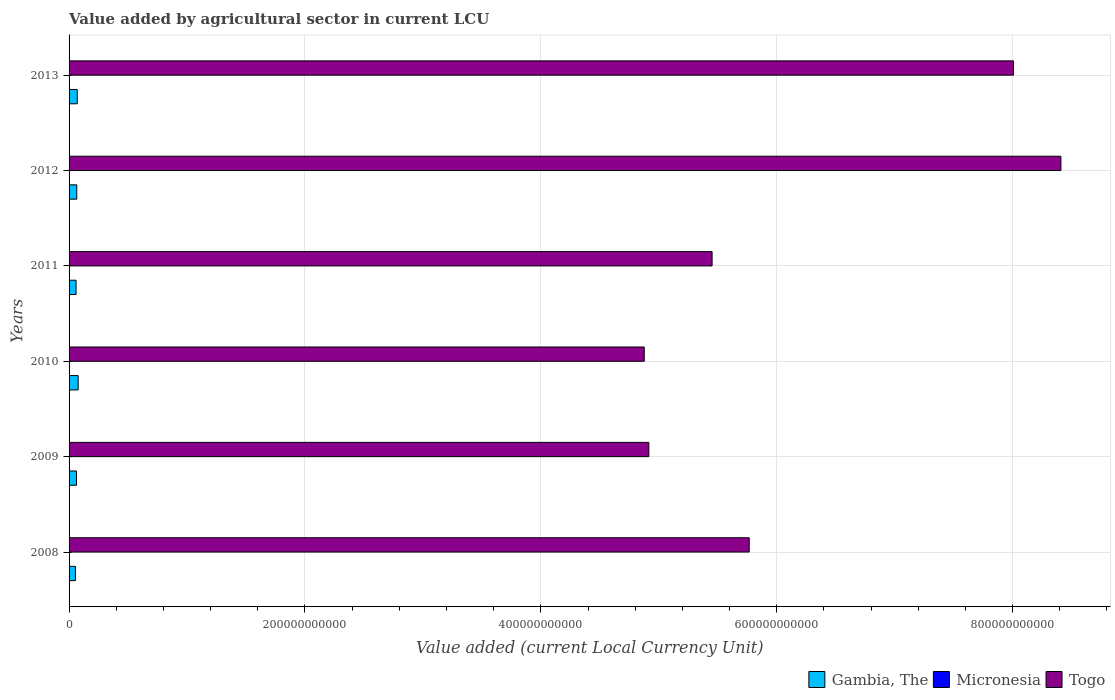Are the number of bars per tick equal to the number of legend labels?
Your response must be concise. Yes. Are the number of bars on each tick of the Y-axis equal?
Your answer should be compact. Yes. How many bars are there on the 3rd tick from the top?
Make the answer very short. 3. What is the label of the 6th group of bars from the top?
Offer a very short reply. 2008. In how many cases, is the number of bars for a given year not equal to the number of legend labels?
Offer a terse response. 0. What is the value added by agricultural sector in Togo in 2008?
Your answer should be very brief. 5.77e+11. Across all years, what is the maximum value added by agricultural sector in Micronesia?
Give a very brief answer. 9.16e+07. Across all years, what is the minimum value added by agricultural sector in Micronesia?
Your answer should be compact. 6.79e+07. In which year was the value added by agricultural sector in Micronesia maximum?
Give a very brief answer. 2012. What is the total value added by agricultural sector in Togo in the graph?
Give a very brief answer. 3.74e+12. What is the difference between the value added by agricultural sector in Togo in 2008 and that in 2012?
Give a very brief answer. -2.64e+11. What is the difference between the value added by agricultural sector in Micronesia in 2009 and the value added by agricultural sector in Gambia, The in 2012?
Make the answer very short. -6.46e+09. What is the average value added by agricultural sector in Micronesia per year?
Ensure brevity in your answer.  7.72e+07. In the year 2013, what is the difference between the value added by agricultural sector in Gambia, The and value added by agricultural sector in Micronesia?
Provide a short and direct response. 6.86e+09. What is the ratio of the value added by agricultural sector in Gambia, The in 2009 to that in 2010?
Offer a terse response. 0.82. What is the difference between the highest and the second highest value added by agricultural sector in Togo?
Your answer should be compact. 4.03e+1. What is the difference between the highest and the lowest value added by agricultural sector in Gambia, The?
Provide a succinct answer. 2.32e+09. What does the 3rd bar from the top in 2013 represents?
Your answer should be very brief. Gambia, The. What does the 3rd bar from the bottom in 2008 represents?
Offer a very short reply. Togo. Is it the case that in every year, the sum of the value added by agricultural sector in Togo and value added by agricultural sector in Micronesia is greater than the value added by agricultural sector in Gambia, The?
Your response must be concise. Yes. What is the difference between two consecutive major ticks on the X-axis?
Provide a succinct answer. 2.00e+11. Are the values on the major ticks of X-axis written in scientific E-notation?
Your response must be concise. No. Does the graph contain grids?
Your answer should be compact. Yes. Where does the legend appear in the graph?
Make the answer very short. Bottom right. How are the legend labels stacked?
Keep it short and to the point. Horizontal. What is the title of the graph?
Provide a succinct answer. Value added by agricultural sector in current LCU. What is the label or title of the X-axis?
Offer a very short reply. Value added (current Local Currency Unit). What is the label or title of the Y-axis?
Ensure brevity in your answer.  Years. What is the Value added (current Local Currency Unit) in Gambia, The in 2008?
Your answer should be very brief. 5.40e+09. What is the Value added (current Local Currency Unit) of Micronesia in 2008?
Make the answer very short. 6.79e+07. What is the Value added (current Local Currency Unit) in Togo in 2008?
Your answer should be compact. 5.77e+11. What is the Value added (current Local Currency Unit) in Gambia, The in 2009?
Ensure brevity in your answer.  6.29e+09. What is the Value added (current Local Currency Unit) in Micronesia in 2009?
Your answer should be compact. 6.84e+07. What is the Value added (current Local Currency Unit) of Togo in 2009?
Offer a very short reply. 4.92e+11. What is the Value added (current Local Currency Unit) of Gambia, The in 2010?
Give a very brief answer. 7.72e+09. What is the Value added (current Local Currency Unit) of Micronesia in 2010?
Provide a short and direct response. 7.13e+07. What is the Value added (current Local Currency Unit) of Togo in 2010?
Your answer should be very brief. 4.88e+11. What is the Value added (current Local Currency Unit) of Gambia, The in 2011?
Provide a short and direct response. 5.94e+09. What is the Value added (current Local Currency Unit) in Micronesia in 2011?
Offer a terse response. 8.02e+07. What is the Value added (current Local Currency Unit) in Togo in 2011?
Give a very brief answer. 5.45e+11. What is the Value added (current Local Currency Unit) of Gambia, The in 2012?
Your answer should be compact. 6.53e+09. What is the Value added (current Local Currency Unit) of Micronesia in 2012?
Your answer should be compact. 9.16e+07. What is the Value added (current Local Currency Unit) in Togo in 2012?
Offer a very short reply. 8.41e+11. What is the Value added (current Local Currency Unit) of Gambia, The in 2013?
Keep it short and to the point. 6.94e+09. What is the Value added (current Local Currency Unit) in Micronesia in 2013?
Keep it short and to the point. 8.35e+07. What is the Value added (current Local Currency Unit) in Togo in 2013?
Your response must be concise. 8.01e+11. Across all years, what is the maximum Value added (current Local Currency Unit) of Gambia, The?
Keep it short and to the point. 7.72e+09. Across all years, what is the maximum Value added (current Local Currency Unit) of Micronesia?
Your response must be concise. 9.16e+07. Across all years, what is the maximum Value added (current Local Currency Unit) of Togo?
Your response must be concise. 8.41e+11. Across all years, what is the minimum Value added (current Local Currency Unit) in Gambia, The?
Provide a succinct answer. 5.40e+09. Across all years, what is the minimum Value added (current Local Currency Unit) in Micronesia?
Your response must be concise. 6.79e+07. Across all years, what is the minimum Value added (current Local Currency Unit) of Togo?
Your answer should be very brief. 4.88e+11. What is the total Value added (current Local Currency Unit) in Gambia, The in the graph?
Offer a very short reply. 3.88e+1. What is the total Value added (current Local Currency Unit) in Micronesia in the graph?
Make the answer very short. 4.63e+08. What is the total Value added (current Local Currency Unit) in Togo in the graph?
Offer a terse response. 3.74e+12. What is the difference between the Value added (current Local Currency Unit) of Gambia, The in 2008 and that in 2009?
Your response must be concise. -8.91e+08. What is the difference between the Value added (current Local Currency Unit) of Micronesia in 2008 and that in 2009?
Your response must be concise. -5.00e+05. What is the difference between the Value added (current Local Currency Unit) in Togo in 2008 and that in 2009?
Keep it short and to the point. 8.51e+1. What is the difference between the Value added (current Local Currency Unit) in Gambia, The in 2008 and that in 2010?
Ensure brevity in your answer.  -2.32e+09. What is the difference between the Value added (current Local Currency Unit) of Micronesia in 2008 and that in 2010?
Offer a very short reply. -3.40e+06. What is the difference between the Value added (current Local Currency Unit) of Togo in 2008 and that in 2010?
Provide a succinct answer. 8.90e+1. What is the difference between the Value added (current Local Currency Unit) in Gambia, The in 2008 and that in 2011?
Your response must be concise. -5.41e+08. What is the difference between the Value added (current Local Currency Unit) in Micronesia in 2008 and that in 2011?
Your response must be concise. -1.23e+07. What is the difference between the Value added (current Local Currency Unit) of Togo in 2008 and that in 2011?
Offer a terse response. 3.15e+1. What is the difference between the Value added (current Local Currency Unit) of Gambia, The in 2008 and that in 2012?
Provide a short and direct response. -1.13e+09. What is the difference between the Value added (current Local Currency Unit) of Micronesia in 2008 and that in 2012?
Provide a short and direct response. -2.37e+07. What is the difference between the Value added (current Local Currency Unit) in Togo in 2008 and that in 2012?
Your answer should be compact. -2.64e+11. What is the difference between the Value added (current Local Currency Unit) in Gambia, The in 2008 and that in 2013?
Offer a terse response. -1.54e+09. What is the difference between the Value added (current Local Currency Unit) in Micronesia in 2008 and that in 2013?
Make the answer very short. -1.56e+07. What is the difference between the Value added (current Local Currency Unit) of Togo in 2008 and that in 2013?
Provide a succinct answer. -2.24e+11. What is the difference between the Value added (current Local Currency Unit) of Gambia, The in 2009 and that in 2010?
Your answer should be compact. -1.43e+09. What is the difference between the Value added (current Local Currency Unit) in Micronesia in 2009 and that in 2010?
Provide a succinct answer. -2.90e+06. What is the difference between the Value added (current Local Currency Unit) in Togo in 2009 and that in 2010?
Offer a terse response. 3.88e+09. What is the difference between the Value added (current Local Currency Unit) in Gambia, The in 2009 and that in 2011?
Offer a terse response. 3.50e+08. What is the difference between the Value added (current Local Currency Unit) of Micronesia in 2009 and that in 2011?
Provide a succinct answer. -1.18e+07. What is the difference between the Value added (current Local Currency Unit) of Togo in 2009 and that in 2011?
Offer a very short reply. -5.36e+1. What is the difference between the Value added (current Local Currency Unit) of Gambia, The in 2009 and that in 2012?
Keep it short and to the point. -2.41e+08. What is the difference between the Value added (current Local Currency Unit) of Micronesia in 2009 and that in 2012?
Offer a terse response. -2.32e+07. What is the difference between the Value added (current Local Currency Unit) of Togo in 2009 and that in 2012?
Provide a succinct answer. -3.49e+11. What is the difference between the Value added (current Local Currency Unit) of Gambia, The in 2009 and that in 2013?
Your response must be concise. -6.47e+08. What is the difference between the Value added (current Local Currency Unit) in Micronesia in 2009 and that in 2013?
Offer a very short reply. -1.51e+07. What is the difference between the Value added (current Local Currency Unit) in Togo in 2009 and that in 2013?
Your answer should be very brief. -3.09e+11. What is the difference between the Value added (current Local Currency Unit) of Gambia, The in 2010 and that in 2011?
Your answer should be compact. 1.78e+09. What is the difference between the Value added (current Local Currency Unit) of Micronesia in 2010 and that in 2011?
Your response must be concise. -8.90e+06. What is the difference between the Value added (current Local Currency Unit) in Togo in 2010 and that in 2011?
Offer a terse response. -5.75e+1. What is the difference between the Value added (current Local Currency Unit) of Gambia, The in 2010 and that in 2012?
Provide a short and direct response. 1.19e+09. What is the difference between the Value added (current Local Currency Unit) in Micronesia in 2010 and that in 2012?
Provide a short and direct response. -2.03e+07. What is the difference between the Value added (current Local Currency Unit) of Togo in 2010 and that in 2012?
Ensure brevity in your answer.  -3.53e+11. What is the difference between the Value added (current Local Currency Unit) in Gambia, The in 2010 and that in 2013?
Your answer should be very brief. 7.81e+08. What is the difference between the Value added (current Local Currency Unit) in Micronesia in 2010 and that in 2013?
Your response must be concise. -1.22e+07. What is the difference between the Value added (current Local Currency Unit) in Togo in 2010 and that in 2013?
Your answer should be compact. -3.13e+11. What is the difference between the Value added (current Local Currency Unit) of Gambia, The in 2011 and that in 2012?
Keep it short and to the point. -5.92e+08. What is the difference between the Value added (current Local Currency Unit) of Micronesia in 2011 and that in 2012?
Provide a short and direct response. -1.14e+07. What is the difference between the Value added (current Local Currency Unit) of Togo in 2011 and that in 2012?
Offer a very short reply. -2.96e+11. What is the difference between the Value added (current Local Currency Unit) in Gambia, The in 2011 and that in 2013?
Your answer should be very brief. -9.97e+08. What is the difference between the Value added (current Local Currency Unit) of Micronesia in 2011 and that in 2013?
Give a very brief answer. -3.30e+06. What is the difference between the Value added (current Local Currency Unit) of Togo in 2011 and that in 2013?
Keep it short and to the point. -2.55e+11. What is the difference between the Value added (current Local Currency Unit) in Gambia, The in 2012 and that in 2013?
Your response must be concise. -4.06e+08. What is the difference between the Value added (current Local Currency Unit) of Micronesia in 2012 and that in 2013?
Provide a short and direct response. 8.10e+06. What is the difference between the Value added (current Local Currency Unit) in Togo in 2012 and that in 2013?
Your answer should be very brief. 4.03e+1. What is the difference between the Value added (current Local Currency Unit) in Gambia, The in 2008 and the Value added (current Local Currency Unit) in Micronesia in 2009?
Your answer should be compact. 5.33e+09. What is the difference between the Value added (current Local Currency Unit) in Gambia, The in 2008 and the Value added (current Local Currency Unit) in Togo in 2009?
Your answer should be compact. -4.86e+11. What is the difference between the Value added (current Local Currency Unit) of Micronesia in 2008 and the Value added (current Local Currency Unit) of Togo in 2009?
Offer a very short reply. -4.91e+11. What is the difference between the Value added (current Local Currency Unit) in Gambia, The in 2008 and the Value added (current Local Currency Unit) in Micronesia in 2010?
Your response must be concise. 5.33e+09. What is the difference between the Value added (current Local Currency Unit) in Gambia, The in 2008 and the Value added (current Local Currency Unit) in Togo in 2010?
Provide a short and direct response. -4.82e+11. What is the difference between the Value added (current Local Currency Unit) of Micronesia in 2008 and the Value added (current Local Currency Unit) of Togo in 2010?
Give a very brief answer. -4.88e+11. What is the difference between the Value added (current Local Currency Unit) of Gambia, The in 2008 and the Value added (current Local Currency Unit) of Micronesia in 2011?
Provide a succinct answer. 5.32e+09. What is the difference between the Value added (current Local Currency Unit) of Gambia, The in 2008 and the Value added (current Local Currency Unit) of Togo in 2011?
Give a very brief answer. -5.40e+11. What is the difference between the Value added (current Local Currency Unit) in Micronesia in 2008 and the Value added (current Local Currency Unit) in Togo in 2011?
Offer a terse response. -5.45e+11. What is the difference between the Value added (current Local Currency Unit) in Gambia, The in 2008 and the Value added (current Local Currency Unit) in Micronesia in 2012?
Provide a succinct answer. 5.31e+09. What is the difference between the Value added (current Local Currency Unit) of Gambia, The in 2008 and the Value added (current Local Currency Unit) of Togo in 2012?
Your answer should be compact. -8.36e+11. What is the difference between the Value added (current Local Currency Unit) of Micronesia in 2008 and the Value added (current Local Currency Unit) of Togo in 2012?
Your answer should be compact. -8.41e+11. What is the difference between the Value added (current Local Currency Unit) in Gambia, The in 2008 and the Value added (current Local Currency Unit) in Micronesia in 2013?
Your answer should be very brief. 5.32e+09. What is the difference between the Value added (current Local Currency Unit) in Gambia, The in 2008 and the Value added (current Local Currency Unit) in Togo in 2013?
Keep it short and to the point. -7.95e+11. What is the difference between the Value added (current Local Currency Unit) of Micronesia in 2008 and the Value added (current Local Currency Unit) of Togo in 2013?
Your response must be concise. -8.01e+11. What is the difference between the Value added (current Local Currency Unit) of Gambia, The in 2009 and the Value added (current Local Currency Unit) of Micronesia in 2010?
Provide a short and direct response. 6.22e+09. What is the difference between the Value added (current Local Currency Unit) of Gambia, The in 2009 and the Value added (current Local Currency Unit) of Togo in 2010?
Provide a succinct answer. -4.81e+11. What is the difference between the Value added (current Local Currency Unit) of Micronesia in 2009 and the Value added (current Local Currency Unit) of Togo in 2010?
Keep it short and to the point. -4.88e+11. What is the difference between the Value added (current Local Currency Unit) in Gambia, The in 2009 and the Value added (current Local Currency Unit) in Micronesia in 2011?
Your answer should be very brief. 6.21e+09. What is the difference between the Value added (current Local Currency Unit) of Gambia, The in 2009 and the Value added (current Local Currency Unit) of Togo in 2011?
Ensure brevity in your answer.  -5.39e+11. What is the difference between the Value added (current Local Currency Unit) of Micronesia in 2009 and the Value added (current Local Currency Unit) of Togo in 2011?
Offer a very short reply. -5.45e+11. What is the difference between the Value added (current Local Currency Unit) of Gambia, The in 2009 and the Value added (current Local Currency Unit) of Micronesia in 2012?
Offer a very short reply. 6.20e+09. What is the difference between the Value added (current Local Currency Unit) in Gambia, The in 2009 and the Value added (current Local Currency Unit) in Togo in 2012?
Make the answer very short. -8.35e+11. What is the difference between the Value added (current Local Currency Unit) in Micronesia in 2009 and the Value added (current Local Currency Unit) in Togo in 2012?
Ensure brevity in your answer.  -8.41e+11. What is the difference between the Value added (current Local Currency Unit) of Gambia, The in 2009 and the Value added (current Local Currency Unit) of Micronesia in 2013?
Give a very brief answer. 6.21e+09. What is the difference between the Value added (current Local Currency Unit) in Gambia, The in 2009 and the Value added (current Local Currency Unit) in Togo in 2013?
Your answer should be very brief. -7.94e+11. What is the difference between the Value added (current Local Currency Unit) in Micronesia in 2009 and the Value added (current Local Currency Unit) in Togo in 2013?
Offer a very short reply. -8.01e+11. What is the difference between the Value added (current Local Currency Unit) of Gambia, The in 2010 and the Value added (current Local Currency Unit) of Micronesia in 2011?
Give a very brief answer. 7.64e+09. What is the difference between the Value added (current Local Currency Unit) in Gambia, The in 2010 and the Value added (current Local Currency Unit) in Togo in 2011?
Give a very brief answer. -5.37e+11. What is the difference between the Value added (current Local Currency Unit) in Micronesia in 2010 and the Value added (current Local Currency Unit) in Togo in 2011?
Offer a very short reply. -5.45e+11. What is the difference between the Value added (current Local Currency Unit) of Gambia, The in 2010 and the Value added (current Local Currency Unit) of Micronesia in 2012?
Provide a short and direct response. 7.63e+09. What is the difference between the Value added (current Local Currency Unit) in Gambia, The in 2010 and the Value added (current Local Currency Unit) in Togo in 2012?
Provide a short and direct response. -8.33e+11. What is the difference between the Value added (current Local Currency Unit) of Micronesia in 2010 and the Value added (current Local Currency Unit) of Togo in 2012?
Provide a short and direct response. -8.41e+11. What is the difference between the Value added (current Local Currency Unit) in Gambia, The in 2010 and the Value added (current Local Currency Unit) in Micronesia in 2013?
Offer a terse response. 7.64e+09. What is the difference between the Value added (current Local Currency Unit) of Gambia, The in 2010 and the Value added (current Local Currency Unit) of Togo in 2013?
Provide a succinct answer. -7.93e+11. What is the difference between the Value added (current Local Currency Unit) of Micronesia in 2010 and the Value added (current Local Currency Unit) of Togo in 2013?
Your answer should be compact. -8.01e+11. What is the difference between the Value added (current Local Currency Unit) in Gambia, The in 2011 and the Value added (current Local Currency Unit) in Micronesia in 2012?
Give a very brief answer. 5.85e+09. What is the difference between the Value added (current Local Currency Unit) of Gambia, The in 2011 and the Value added (current Local Currency Unit) of Togo in 2012?
Give a very brief answer. -8.35e+11. What is the difference between the Value added (current Local Currency Unit) in Micronesia in 2011 and the Value added (current Local Currency Unit) in Togo in 2012?
Your answer should be very brief. -8.41e+11. What is the difference between the Value added (current Local Currency Unit) of Gambia, The in 2011 and the Value added (current Local Currency Unit) of Micronesia in 2013?
Your response must be concise. 5.86e+09. What is the difference between the Value added (current Local Currency Unit) in Gambia, The in 2011 and the Value added (current Local Currency Unit) in Togo in 2013?
Your answer should be compact. -7.95e+11. What is the difference between the Value added (current Local Currency Unit) of Micronesia in 2011 and the Value added (current Local Currency Unit) of Togo in 2013?
Provide a succinct answer. -8.01e+11. What is the difference between the Value added (current Local Currency Unit) in Gambia, The in 2012 and the Value added (current Local Currency Unit) in Micronesia in 2013?
Offer a very short reply. 6.45e+09. What is the difference between the Value added (current Local Currency Unit) in Gambia, The in 2012 and the Value added (current Local Currency Unit) in Togo in 2013?
Give a very brief answer. -7.94e+11. What is the difference between the Value added (current Local Currency Unit) in Micronesia in 2012 and the Value added (current Local Currency Unit) in Togo in 2013?
Your answer should be compact. -8.01e+11. What is the average Value added (current Local Currency Unit) in Gambia, The per year?
Provide a succinct answer. 6.47e+09. What is the average Value added (current Local Currency Unit) in Micronesia per year?
Your answer should be compact. 7.72e+07. What is the average Value added (current Local Currency Unit) in Togo per year?
Keep it short and to the point. 6.24e+11. In the year 2008, what is the difference between the Value added (current Local Currency Unit) of Gambia, The and Value added (current Local Currency Unit) of Micronesia?
Ensure brevity in your answer.  5.33e+09. In the year 2008, what is the difference between the Value added (current Local Currency Unit) of Gambia, The and Value added (current Local Currency Unit) of Togo?
Your answer should be compact. -5.71e+11. In the year 2008, what is the difference between the Value added (current Local Currency Unit) of Micronesia and Value added (current Local Currency Unit) of Togo?
Offer a very short reply. -5.77e+11. In the year 2009, what is the difference between the Value added (current Local Currency Unit) of Gambia, The and Value added (current Local Currency Unit) of Micronesia?
Make the answer very short. 6.22e+09. In the year 2009, what is the difference between the Value added (current Local Currency Unit) of Gambia, The and Value added (current Local Currency Unit) of Togo?
Offer a terse response. -4.85e+11. In the year 2009, what is the difference between the Value added (current Local Currency Unit) in Micronesia and Value added (current Local Currency Unit) in Togo?
Make the answer very short. -4.91e+11. In the year 2010, what is the difference between the Value added (current Local Currency Unit) in Gambia, The and Value added (current Local Currency Unit) in Micronesia?
Your answer should be compact. 7.65e+09. In the year 2010, what is the difference between the Value added (current Local Currency Unit) of Gambia, The and Value added (current Local Currency Unit) of Togo?
Your answer should be very brief. -4.80e+11. In the year 2010, what is the difference between the Value added (current Local Currency Unit) in Micronesia and Value added (current Local Currency Unit) in Togo?
Make the answer very short. -4.88e+11. In the year 2011, what is the difference between the Value added (current Local Currency Unit) of Gambia, The and Value added (current Local Currency Unit) of Micronesia?
Your response must be concise. 5.86e+09. In the year 2011, what is the difference between the Value added (current Local Currency Unit) in Gambia, The and Value added (current Local Currency Unit) in Togo?
Ensure brevity in your answer.  -5.39e+11. In the year 2011, what is the difference between the Value added (current Local Currency Unit) in Micronesia and Value added (current Local Currency Unit) in Togo?
Give a very brief answer. -5.45e+11. In the year 2012, what is the difference between the Value added (current Local Currency Unit) in Gambia, The and Value added (current Local Currency Unit) in Micronesia?
Make the answer very short. 6.44e+09. In the year 2012, what is the difference between the Value added (current Local Currency Unit) of Gambia, The and Value added (current Local Currency Unit) of Togo?
Offer a terse response. -8.34e+11. In the year 2012, what is the difference between the Value added (current Local Currency Unit) of Micronesia and Value added (current Local Currency Unit) of Togo?
Your response must be concise. -8.41e+11. In the year 2013, what is the difference between the Value added (current Local Currency Unit) of Gambia, The and Value added (current Local Currency Unit) of Micronesia?
Your answer should be very brief. 6.86e+09. In the year 2013, what is the difference between the Value added (current Local Currency Unit) of Gambia, The and Value added (current Local Currency Unit) of Togo?
Make the answer very short. -7.94e+11. In the year 2013, what is the difference between the Value added (current Local Currency Unit) in Micronesia and Value added (current Local Currency Unit) in Togo?
Your answer should be compact. -8.01e+11. What is the ratio of the Value added (current Local Currency Unit) of Gambia, The in 2008 to that in 2009?
Your response must be concise. 0.86. What is the ratio of the Value added (current Local Currency Unit) in Micronesia in 2008 to that in 2009?
Keep it short and to the point. 0.99. What is the ratio of the Value added (current Local Currency Unit) in Togo in 2008 to that in 2009?
Ensure brevity in your answer.  1.17. What is the ratio of the Value added (current Local Currency Unit) of Gambia, The in 2008 to that in 2010?
Offer a very short reply. 0.7. What is the ratio of the Value added (current Local Currency Unit) of Micronesia in 2008 to that in 2010?
Offer a terse response. 0.95. What is the ratio of the Value added (current Local Currency Unit) in Togo in 2008 to that in 2010?
Make the answer very short. 1.18. What is the ratio of the Value added (current Local Currency Unit) of Gambia, The in 2008 to that in 2011?
Offer a very short reply. 0.91. What is the ratio of the Value added (current Local Currency Unit) in Micronesia in 2008 to that in 2011?
Your answer should be compact. 0.85. What is the ratio of the Value added (current Local Currency Unit) in Togo in 2008 to that in 2011?
Your response must be concise. 1.06. What is the ratio of the Value added (current Local Currency Unit) of Gambia, The in 2008 to that in 2012?
Ensure brevity in your answer.  0.83. What is the ratio of the Value added (current Local Currency Unit) of Micronesia in 2008 to that in 2012?
Make the answer very short. 0.74. What is the ratio of the Value added (current Local Currency Unit) of Togo in 2008 to that in 2012?
Keep it short and to the point. 0.69. What is the ratio of the Value added (current Local Currency Unit) of Gambia, The in 2008 to that in 2013?
Ensure brevity in your answer.  0.78. What is the ratio of the Value added (current Local Currency Unit) of Micronesia in 2008 to that in 2013?
Provide a short and direct response. 0.81. What is the ratio of the Value added (current Local Currency Unit) of Togo in 2008 to that in 2013?
Make the answer very short. 0.72. What is the ratio of the Value added (current Local Currency Unit) in Gambia, The in 2009 to that in 2010?
Give a very brief answer. 0.81. What is the ratio of the Value added (current Local Currency Unit) of Micronesia in 2009 to that in 2010?
Give a very brief answer. 0.96. What is the ratio of the Value added (current Local Currency Unit) in Togo in 2009 to that in 2010?
Your answer should be very brief. 1.01. What is the ratio of the Value added (current Local Currency Unit) in Gambia, The in 2009 to that in 2011?
Your answer should be very brief. 1.06. What is the ratio of the Value added (current Local Currency Unit) in Micronesia in 2009 to that in 2011?
Give a very brief answer. 0.85. What is the ratio of the Value added (current Local Currency Unit) in Togo in 2009 to that in 2011?
Provide a succinct answer. 0.9. What is the ratio of the Value added (current Local Currency Unit) of Micronesia in 2009 to that in 2012?
Make the answer very short. 0.75. What is the ratio of the Value added (current Local Currency Unit) of Togo in 2009 to that in 2012?
Give a very brief answer. 0.58. What is the ratio of the Value added (current Local Currency Unit) in Gambia, The in 2009 to that in 2013?
Keep it short and to the point. 0.91. What is the ratio of the Value added (current Local Currency Unit) in Micronesia in 2009 to that in 2013?
Provide a succinct answer. 0.82. What is the ratio of the Value added (current Local Currency Unit) of Togo in 2009 to that in 2013?
Provide a short and direct response. 0.61. What is the ratio of the Value added (current Local Currency Unit) of Gambia, The in 2010 to that in 2011?
Provide a succinct answer. 1.3. What is the ratio of the Value added (current Local Currency Unit) of Micronesia in 2010 to that in 2011?
Provide a short and direct response. 0.89. What is the ratio of the Value added (current Local Currency Unit) in Togo in 2010 to that in 2011?
Offer a very short reply. 0.89. What is the ratio of the Value added (current Local Currency Unit) of Gambia, The in 2010 to that in 2012?
Offer a terse response. 1.18. What is the ratio of the Value added (current Local Currency Unit) in Micronesia in 2010 to that in 2012?
Your answer should be compact. 0.78. What is the ratio of the Value added (current Local Currency Unit) of Togo in 2010 to that in 2012?
Offer a very short reply. 0.58. What is the ratio of the Value added (current Local Currency Unit) in Gambia, The in 2010 to that in 2013?
Give a very brief answer. 1.11. What is the ratio of the Value added (current Local Currency Unit) of Micronesia in 2010 to that in 2013?
Ensure brevity in your answer.  0.85. What is the ratio of the Value added (current Local Currency Unit) in Togo in 2010 to that in 2013?
Ensure brevity in your answer.  0.61. What is the ratio of the Value added (current Local Currency Unit) in Gambia, The in 2011 to that in 2012?
Provide a succinct answer. 0.91. What is the ratio of the Value added (current Local Currency Unit) of Micronesia in 2011 to that in 2012?
Offer a very short reply. 0.88. What is the ratio of the Value added (current Local Currency Unit) in Togo in 2011 to that in 2012?
Provide a short and direct response. 0.65. What is the ratio of the Value added (current Local Currency Unit) in Gambia, The in 2011 to that in 2013?
Your response must be concise. 0.86. What is the ratio of the Value added (current Local Currency Unit) in Micronesia in 2011 to that in 2013?
Provide a short and direct response. 0.96. What is the ratio of the Value added (current Local Currency Unit) of Togo in 2011 to that in 2013?
Your answer should be compact. 0.68. What is the ratio of the Value added (current Local Currency Unit) in Gambia, The in 2012 to that in 2013?
Your response must be concise. 0.94. What is the ratio of the Value added (current Local Currency Unit) of Micronesia in 2012 to that in 2013?
Ensure brevity in your answer.  1.1. What is the ratio of the Value added (current Local Currency Unit) in Togo in 2012 to that in 2013?
Make the answer very short. 1.05. What is the difference between the highest and the second highest Value added (current Local Currency Unit) in Gambia, The?
Your answer should be very brief. 7.81e+08. What is the difference between the highest and the second highest Value added (current Local Currency Unit) of Micronesia?
Your answer should be compact. 8.10e+06. What is the difference between the highest and the second highest Value added (current Local Currency Unit) of Togo?
Your answer should be compact. 4.03e+1. What is the difference between the highest and the lowest Value added (current Local Currency Unit) of Gambia, The?
Provide a succinct answer. 2.32e+09. What is the difference between the highest and the lowest Value added (current Local Currency Unit) of Micronesia?
Give a very brief answer. 2.37e+07. What is the difference between the highest and the lowest Value added (current Local Currency Unit) in Togo?
Offer a very short reply. 3.53e+11. 